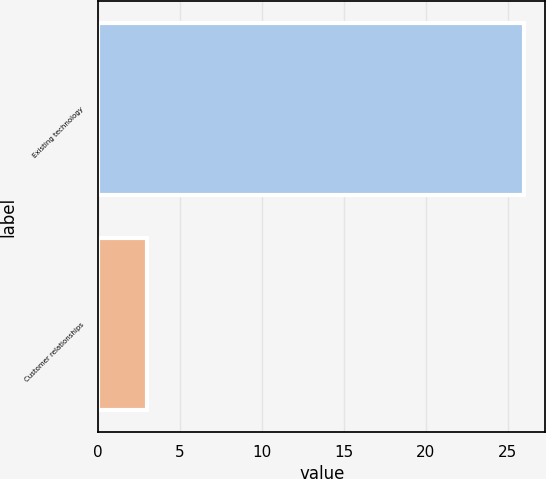Convert chart. <chart><loc_0><loc_0><loc_500><loc_500><bar_chart><fcel>Existing technology<fcel>Customer relationships<nl><fcel>26<fcel>3<nl></chart> 